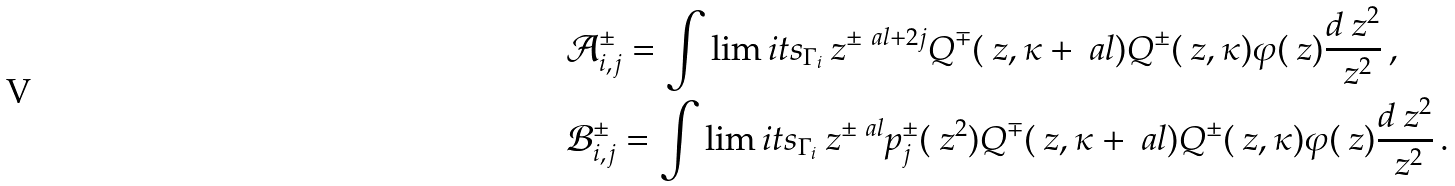Convert formula to latex. <formula><loc_0><loc_0><loc_500><loc_500>& \mathcal { A } ^ { \pm } _ { i , j } = \int \lim i t s _ { \Gamma _ { i } } \ z ^ { \pm \ a l + 2 j } Q ^ { \mp } ( \ z , \kappa + \ a l ) Q ^ { \pm } ( \ z , \kappa ) \varphi ( \ z ) \frac { d \ z ^ { 2 } } { \ z ^ { 2 } } \, , \\ & \mathcal { B } ^ { \pm } _ { i , j } = \int \lim i t s _ { \Gamma _ { i } } \ z ^ { \pm \ a l } p ^ { \pm } _ { j } ( \ z ^ { 2 } ) Q ^ { \mp } ( \ z , \kappa + \ a l ) Q ^ { \pm } ( \ z , \kappa ) \varphi ( \ z ) \frac { d \ z ^ { 2 } } { \ z ^ { 2 } } \, .</formula> 